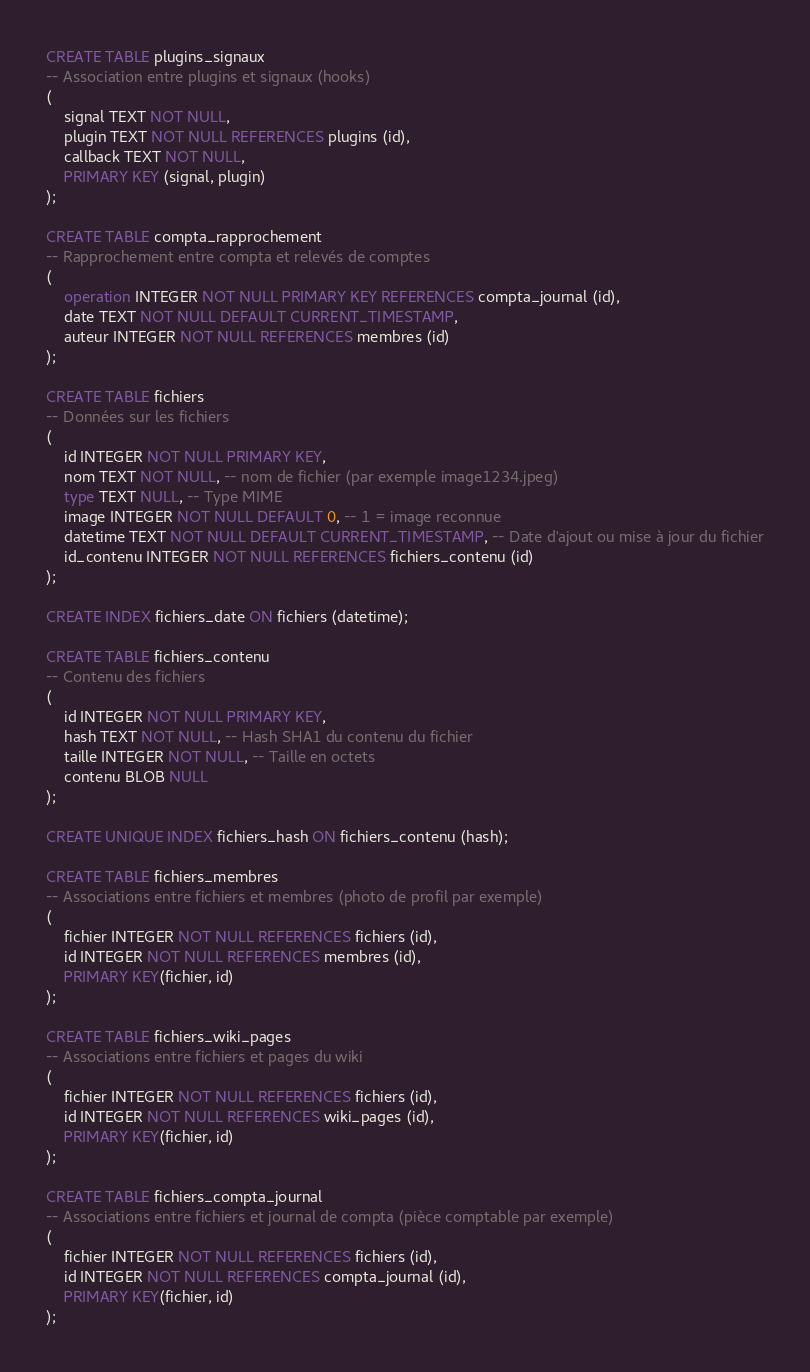Convert code to text. <code><loc_0><loc_0><loc_500><loc_500><_SQL_>CREATE TABLE plugins_signaux
-- Association entre plugins et signaux (hooks)
(
    signal TEXT NOT NULL,
    plugin TEXT NOT NULL REFERENCES plugins (id),
    callback TEXT NOT NULL,
    PRIMARY KEY (signal, plugin)
);

CREATE TABLE compta_rapprochement
-- Rapprochement entre compta et relevés de comptes
(
    operation INTEGER NOT NULL PRIMARY KEY REFERENCES compta_journal (id),
    date TEXT NOT NULL DEFAULT CURRENT_TIMESTAMP,
    auteur INTEGER NOT NULL REFERENCES membres (id)
);

CREATE TABLE fichiers
-- Données sur les fichiers
(
    id INTEGER NOT NULL PRIMARY KEY,
    nom TEXT NOT NULL, -- nom de fichier (par exemple image1234.jpeg)
    type TEXT NULL, -- Type MIME
    image INTEGER NOT NULL DEFAULT 0, -- 1 = image reconnue
    datetime TEXT NOT NULL DEFAULT CURRENT_TIMESTAMP, -- Date d'ajout ou mise à jour du fichier
    id_contenu INTEGER NOT NULL REFERENCES fichiers_contenu (id)
);

CREATE INDEX fichiers_date ON fichiers (datetime);

CREATE TABLE fichiers_contenu
-- Contenu des fichiers
(
    id INTEGER NOT NULL PRIMARY KEY,
    hash TEXT NOT NULL, -- Hash SHA1 du contenu du fichier
    taille INTEGER NOT NULL, -- Taille en octets
    contenu BLOB NULL
);

CREATE UNIQUE INDEX fichiers_hash ON fichiers_contenu (hash);

CREATE TABLE fichiers_membres
-- Associations entre fichiers et membres (photo de profil par exemple)
(
    fichier INTEGER NOT NULL REFERENCES fichiers (id),
    id INTEGER NOT NULL REFERENCES membres (id),
    PRIMARY KEY(fichier, id)
);

CREATE TABLE fichiers_wiki_pages
-- Associations entre fichiers et pages du wiki
(
    fichier INTEGER NOT NULL REFERENCES fichiers (id),
    id INTEGER NOT NULL REFERENCES wiki_pages (id),
    PRIMARY KEY(fichier, id)
);

CREATE TABLE fichiers_compta_journal
-- Associations entre fichiers et journal de compta (pièce comptable par exemple)
(
    fichier INTEGER NOT NULL REFERENCES fichiers (id),
    id INTEGER NOT NULL REFERENCES compta_journal (id),
    PRIMARY KEY(fichier, id)
);</code> 